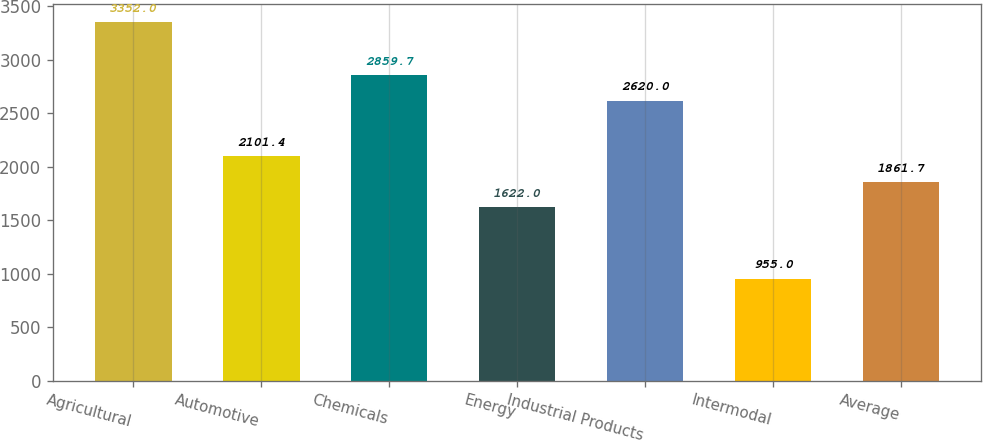Convert chart to OTSL. <chart><loc_0><loc_0><loc_500><loc_500><bar_chart><fcel>Agricultural<fcel>Automotive<fcel>Chemicals<fcel>Energy<fcel>Industrial Products<fcel>Intermodal<fcel>Average<nl><fcel>3352<fcel>2101.4<fcel>2859.7<fcel>1622<fcel>2620<fcel>955<fcel>1861.7<nl></chart> 